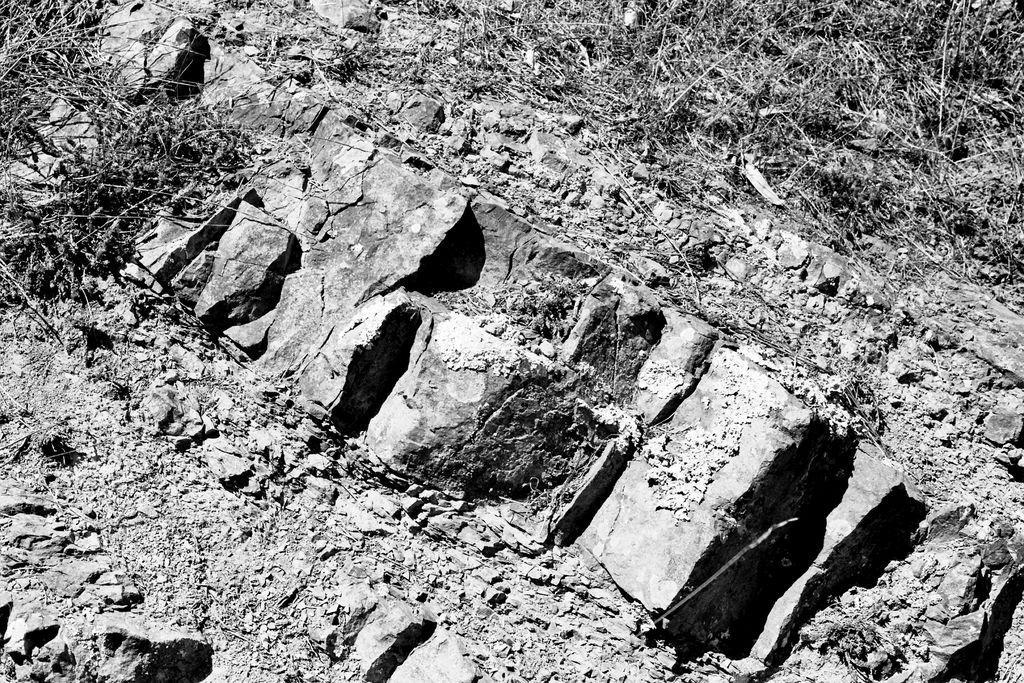How would you summarize this image in a sentence or two? This is the picture of a land. In this image there are stones and there is mud and there are plants. 